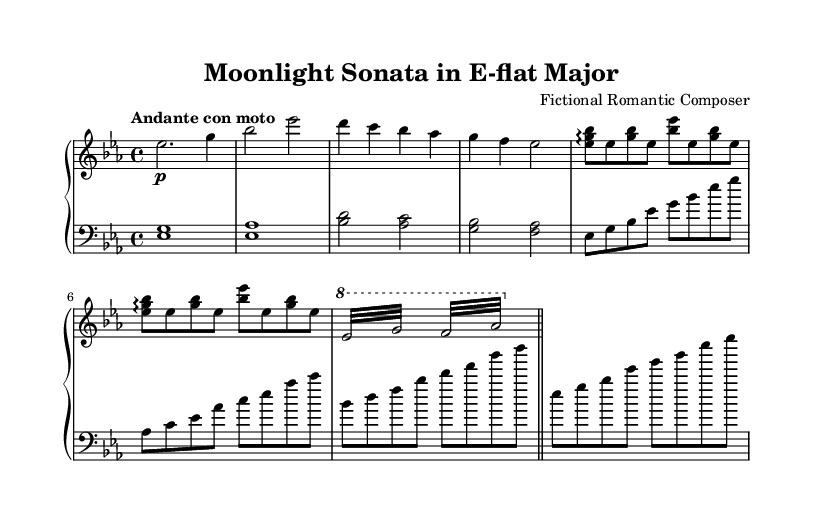What is the key signature of this music? The key signature shows two flats, indicating that the piece is in E-flat major. The flats are located on the B and E lines in the staff.
Answer: E-flat major What is the time signature of this music? The time signature is displayed at the beginning of the staff as four beats per measure, which is indicated by the "4/4" notation.
Answer: 4/4 What is the tempo marking for this piece? The tempo marking is shown above the staff, reading "Andante con moto," suggesting a moderately slow tempo with motion.
Answer: Andante con moto How many measures does the right hand part contain? By counting the individual segments separated by bar lines in the right hand part, there are a total of 8 measures.
Answer: 8 What is the last note in the left hand? The last note is represented as a G on the bass clef, placed at the bottom line of the staff.
Answer: G Which dynamic marking is indicated in the right hand? The marking is indicated by the "p" placed after the first note, meaning "piano" or soft dynamics for that section.
Answer: piano What is the figure for the left hand in measure 5? The left hand in measure 5 shows a double note figure, written as <g bes>, indicating the simultaneous playing of G and B-flat.
Answer: <g bes> 